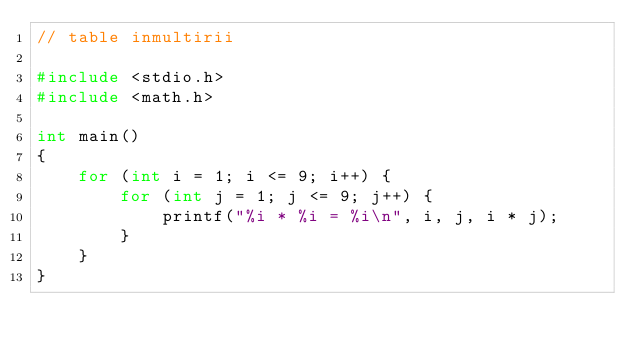<code> <loc_0><loc_0><loc_500><loc_500><_C++_>// table inmultirii

#include <stdio.h>
#include <math.h>

int main()
{
    for (int i = 1; i <= 9; i++) {
        for (int j = 1; j <= 9; j++) {
            printf("%i * %i = %i\n", i, j, i * j);
        }
    }
}</code> 